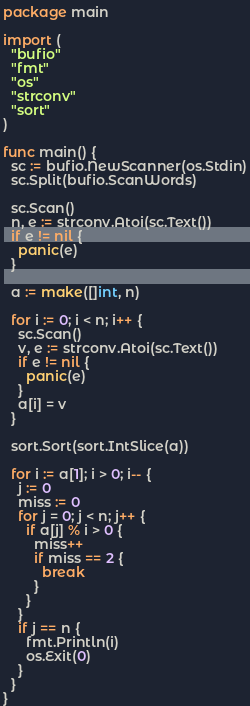Convert code to text. <code><loc_0><loc_0><loc_500><loc_500><_Go_>package main

import (
  "bufio"
  "fmt"
  "os"
  "strconv"
  "sort"
)

func main() {
  sc := bufio.NewScanner(os.Stdin)
  sc.Split(bufio.ScanWords)

  sc.Scan()
  n, e := strconv.Atoi(sc.Text())
  if e != nil {
    panic(e)
  }

  a := make([]int, n)

  for i := 0; i < n; i++ {
    sc.Scan()
    v, e := strconv.Atoi(sc.Text())
    if e != nil {
      panic(e)
    }
    a[i] = v
  }

  sort.Sort(sort.IntSlice(a))

  for i := a[1]; i > 0; i-- {
    j := 0
    miss := 0
    for j = 0; j < n; j++ {
      if a[j] % i > 0 {
        miss++
        if miss == 2 {
          break
        }
      }
    }
    if j == n {
      fmt.Println(i)
      os.Exit(0)
    }
  }
}
</code> 